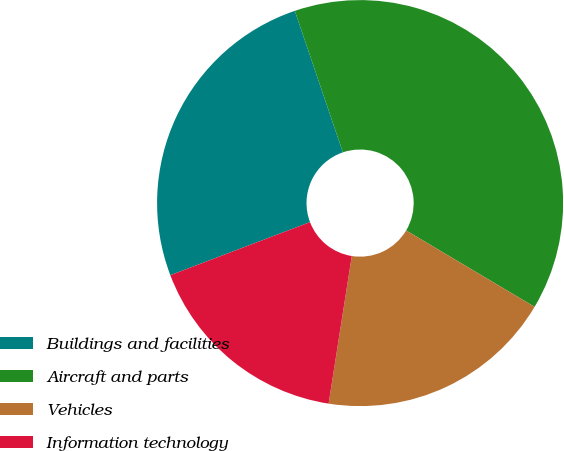Convert chart to OTSL. <chart><loc_0><loc_0><loc_500><loc_500><pie_chart><fcel>Buildings and facilities<fcel>Aircraft and parts<fcel>Vehicles<fcel>Information technology<nl><fcel>25.57%<fcel>38.75%<fcel>18.94%<fcel>16.74%<nl></chart> 